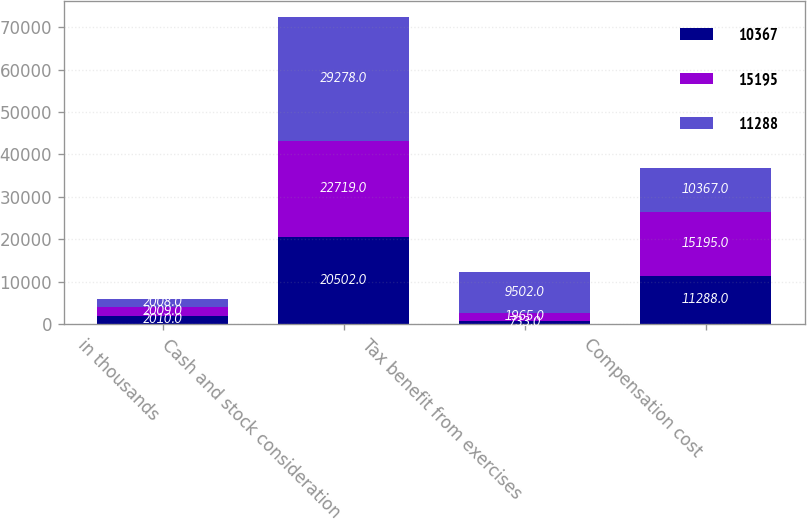Convert chart. <chart><loc_0><loc_0><loc_500><loc_500><stacked_bar_chart><ecel><fcel>in thousands<fcel>Cash and stock consideration<fcel>Tax benefit from exercises<fcel>Compensation cost<nl><fcel>10367<fcel>2010<fcel>20502<fcel>733<fcel>11288<nl><fcel>15195<fcel>2009<fcel>22719<fcel>1965<fcel>15195<nl><fcel>11288<fcel>2008<fcel>29278<fcel>9502<fcel>10367<nl></chart> 